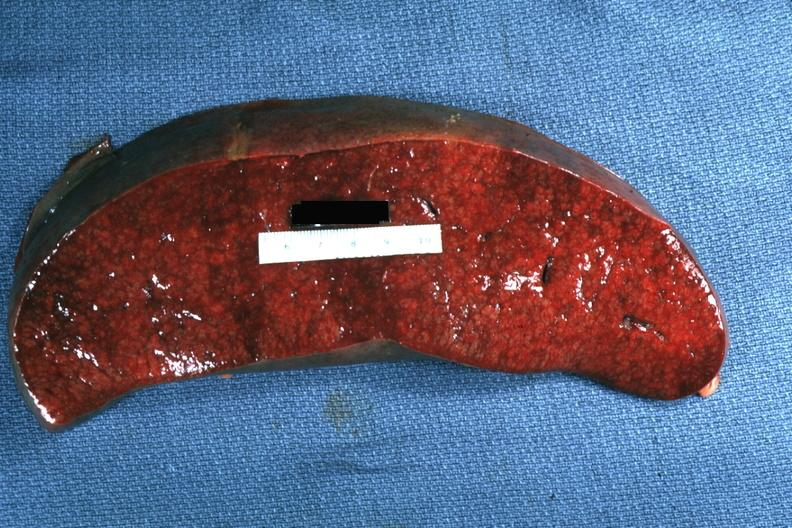how does this image show cut surface?
Answer the question using a single word or phrase. With apparent infiltrative process case of chronic lymphocytic leukemia progressing to acute lymphocytic leukemia 